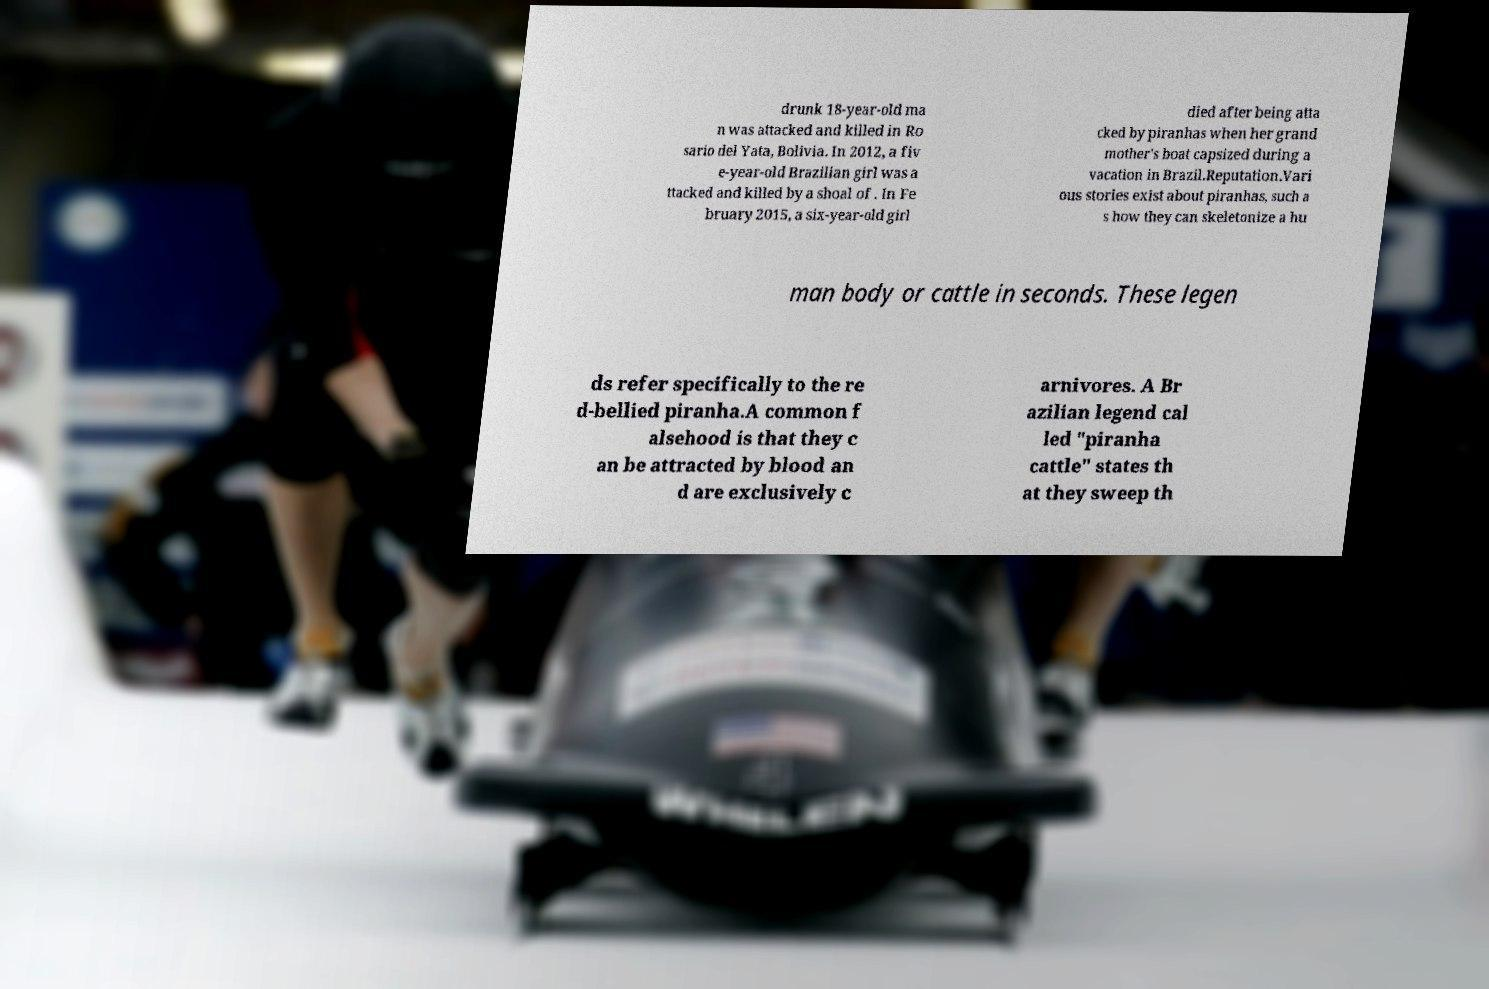Could you extract and type out the text from this image? drunk 18-year-old ma n was attacked and killed in Ro sario del Yata, Bolivia. In 2012, a fiv e-year-old Brazilian girl was a ttacked and killed by a shoal of . In Fe bruary 2015, a six-year-old girl died after being atta cked by piranhas when her grand mother's boat capsized during a vacation in Brazil.Reputation.Vari ous stories exist about piranhas, such a s how they can skeletonize a hu man body or cattle in seconds. These legen ds refer specifically to the re d-bellied piranha.A common f alsehood is that they c an be attracted by blood an d are exclusively c arnivores. A Br azilian legend cal led "piranha cattle" states th at they sweep th 